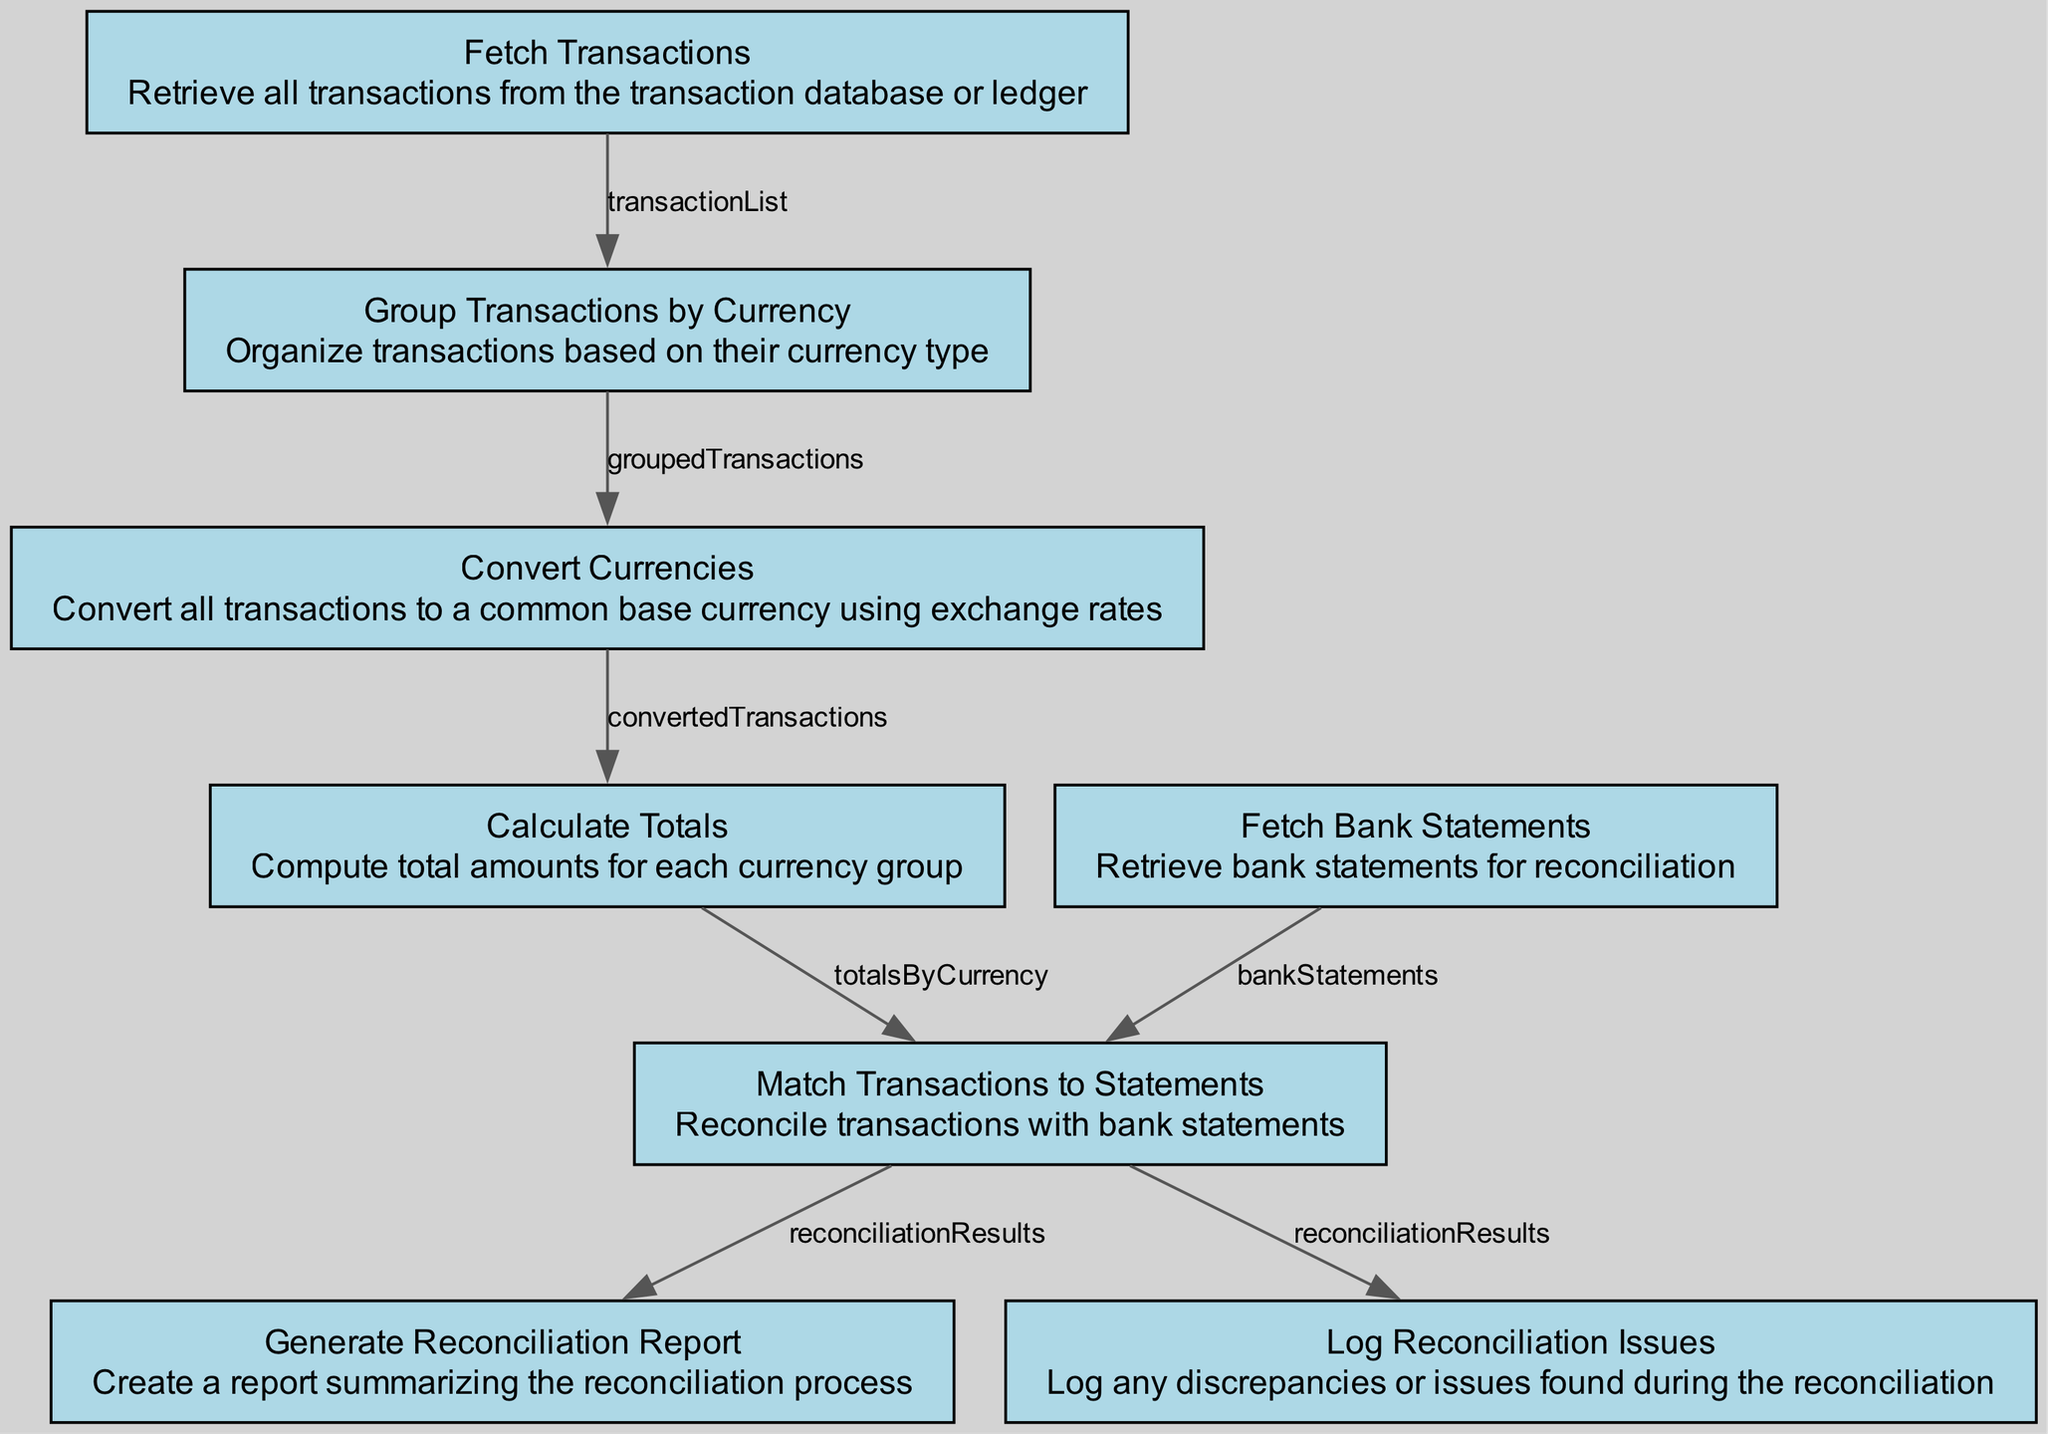What is the first step in the transaction reconciliation process? The first step is "Fetch Transactions" which retrieves all transactions from the transaction database or ledger. This is indicated as the starting point in the flow chart.
Answer: Fetch Transactions How many total nodes are in the flow chart? By counting each distinct step in the diagram, I can identify 8 nodes total, each representing a critical function in the reconciliation process.
Answer: 8 What does the "Convert Currencies" step output? The "Convert Currencies" step outputs "convertedTransactions", as indicated in the outputs section of that node in the diagram.
Answer: convertedTransactions Which step retrieves bank statements? The step labeled "Fetch Bank Statements" is responsible for retrieving bank statements, as described in its description.
Answer: Fetch Bank Statements What are the inputs required for the "Match Transactions to Statements" step? The "Match Transactions to Statements" step requires two inputs: "totalsByCurrency" and "bankStatements" as shown in the diagram.
Answer: totalsByCurrency and bankStatements How many outputs does the "Group Transactions by Currency" step have? The "Group Transactions by Currency" step has one output: "groupedTransactions", confirmed by looking at the outputs listed for that particular node.
Answer: 1 What is generated after the reconciliation results are produced? After the reconciliation results are produced, the next step generates a "Reconciliation Report," which summarizes the process.
Answer: Reconciliation Report In what order do the steps follow after "Calculate Totals"? Immediately after "Calculate Totals," the next steps are "Fetch Bank Statements," followed by "Match Transactions to Statements" in the flow of the diagram.
Answer: Fetch Bank Statements, Match Transactions to Statements What issues are logged during the reconciliation process? The "Log Reconciliation Issues" step logs any discrepancies or issues found during the reconciliation as per its description.
Answer: Discrepancies or issues 